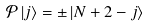<formula> <loc_0><loc_0><loc_500><loc_500>\mathcal { P } \left | j \right \rangle = \pm \left | N + 2 - j \right \rangle</formula> 